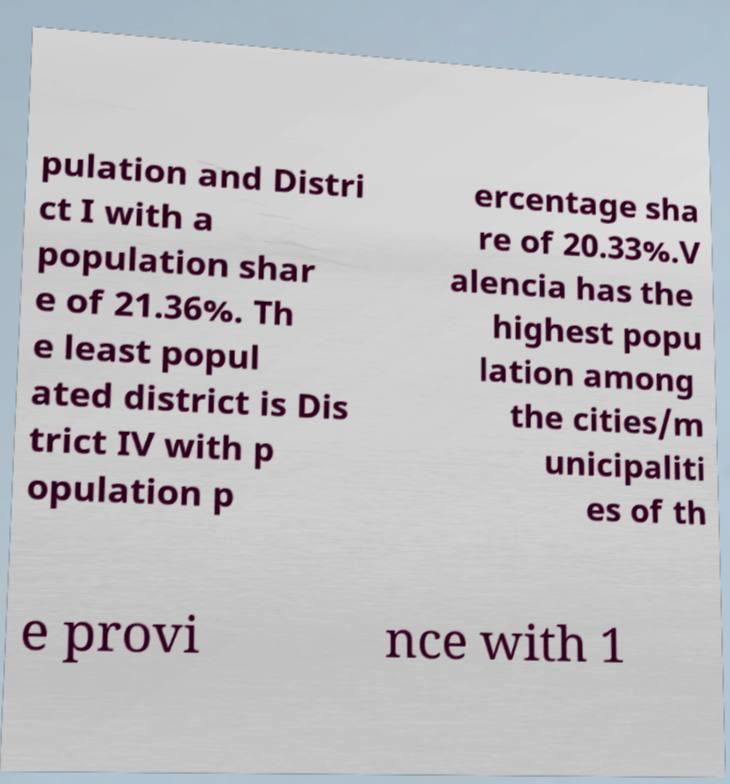Please read and relay the text visible in this image. What does it say? pulation and Distri ct I with a population shar e of 21.36%. Th e least popul ated district is Dis trict IV with p opulation p ercentage sha re of 20.33%.V alencia has the highest popu lation among the cities/m unicipaliti es of th e provi nce with 1 